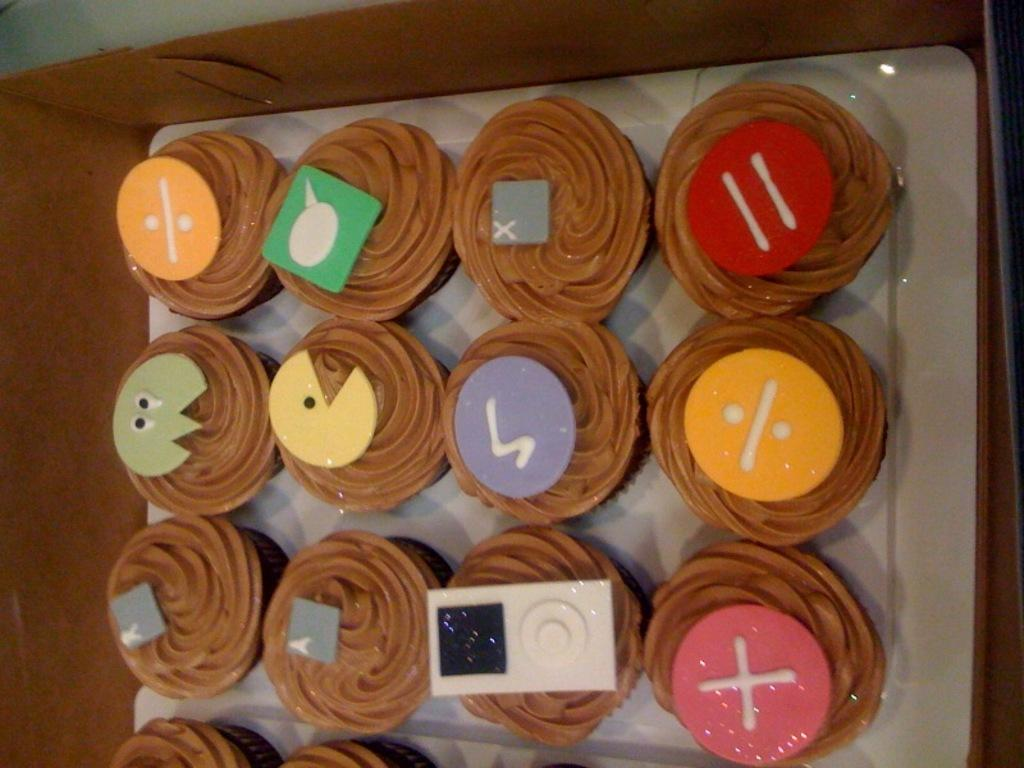What is present in the image? There are food items in the image. How are the food items arranged or contained? The food items are in a box. How many elbows can be seen in the image? There are no elbows visible in the image. What type of room is shown in the image? The image does not depict a room; it only shows food items in a box. 